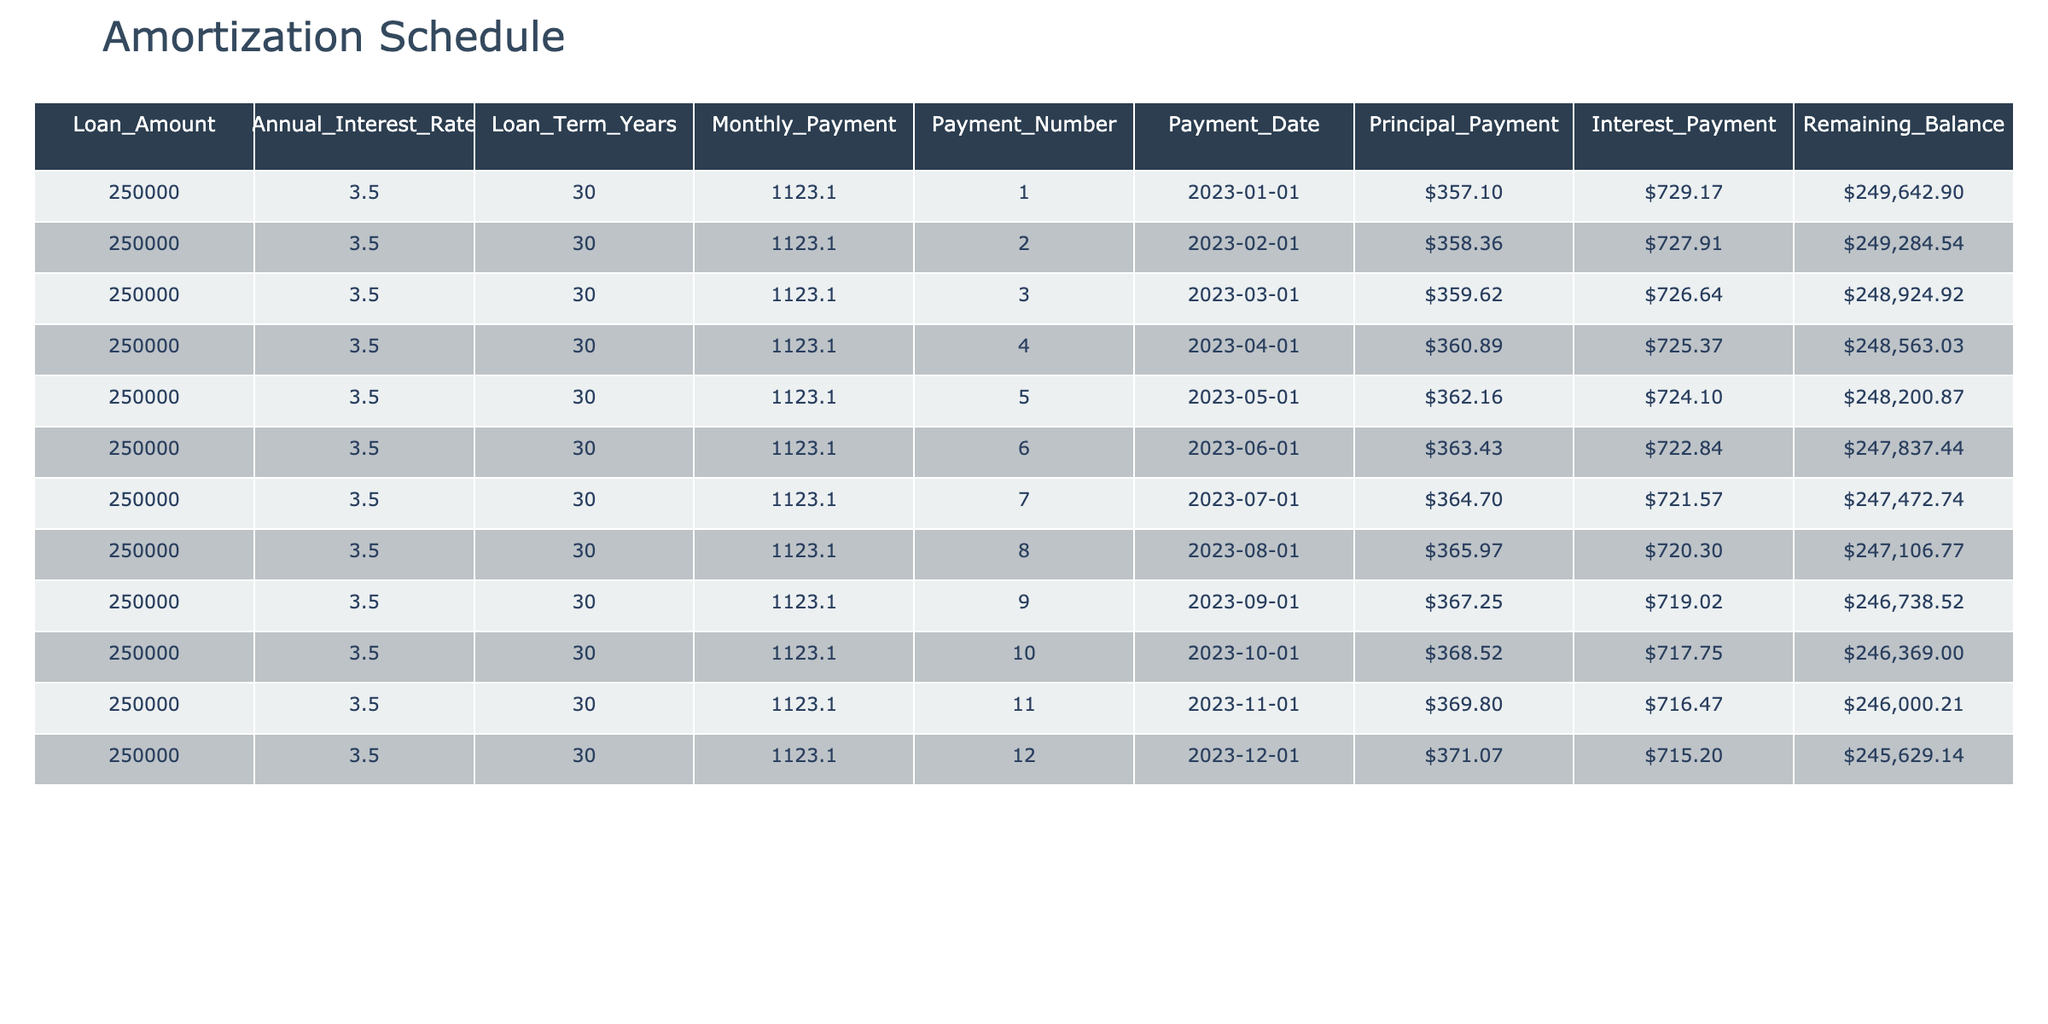What is the monthly payment amount for this mortgage? The monthly payment amount is explicitly listed in the table under the “Monthly_Payment” column for each row, and it remains consistent throughout the table. Therefore, it can be directly retrieved as $1,123.10.
Answer: $1,123.10 What is the total amount of principal paid after the first three payments? To find the total principal paid after the first three payments, we add the values in the "Principal_Payment" column for the first three rows: $357.10 + $358.36 + $359.62 = $1,075.08.
Answer: $1,075.08 Is the interest payment decreasing over time? Observing the "Interest_Payment" column, we see that the values decrease from $729.17 in the first payment to $715.20 in the twelfth payment. Since all values are consistently decreasing, the statement is true.
Answer: Yes What is the remaining balance after the first payment? The remaining balance after the first payment can be found in the "Remaining_Balance” column for the first row, which is $249,642.90 after the first payment is applied.
Answer: $249,642.90 What is the average monthly principal payment over the first twelve months? To find the average monthly principal payment, we first sum the "Principal_Payment" amounts in the first twelve rows: $357.10 + $358.36 + $359.62 + $360.89 + $362.16 + $363.43 + $364.70 + $365.97 + $367.25 + $368.52 + $369.80 + $371.07 = $4,398.54. Next, we divide by 12 (the number of payments): $4,398.54 / 12 ≈ $366.54.
Answer: $366.54 What is the total interest paid after the first six payments? To calculate the total interest paid after the first six payments, sum the values in the "Interest_Payment" column for the first six rows: $729.17 + $727.91 + $726.64 + $725.37 + $724.10 + $722.84 = $4,455.03.
Answer: $4,455.03 What is the remaining balance after the tenth payment? Looking for the "Remaining_Balance" on the row for the tenth payment, we find the value is $246,369.00. This balance reflects the mortgage amount after ten payments have been processed.
Answer: $246,369.00 Are any principal payments above $360.00 in the first six months? Examining the "Principal_Payment" column for the first six payments, we see the values are $357.10, $358.36, $359.62, $360.89, $362.16, and $363.43. Since $360.89, $362.16, and $363.43 are above $360.00, the answer is yes.
Answer: Yes 